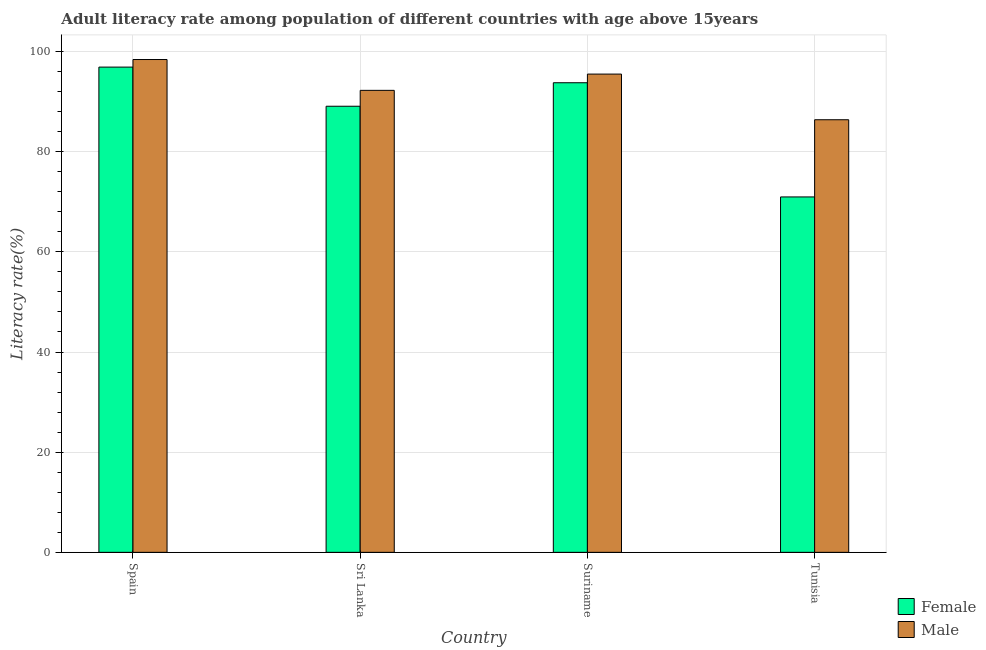Are the number of bars on each tick of the X-axis equal?
Make the answer very short. Yes. What is the label of the 2nd group of bars from the left?
Your response must be concise. Sri Lanka. In how many cases, is the number of bars for a given country not equal to the number of legend labels?
Ensure brevity in your answer.  0. What is the male adult literacy rate in Sri Lanka?
Your answer should be compact. 92.24. Across all countries, what is the maximum female adult literacy rate?
Your answer should be very brief. 96.89. Across all countries, what is the minimum male adult literacy rate?
Give a very brief answer. 86.38. In which country was the male adult literacy rate maximum?
Provide a short and direct response. Spain. In which country was the female adult literacy rate minimum?
Provide a short and direct response. Tunisia. What is the total female adult literacy rate in the graph?
Ensure brevity in your answer.  350.69. What is the difference between the male adult literacy rate in Spain and that in Sri Lanka?
Keep it short and to the point. 6.16. What is the difference between the female adult literacy rate in Sri Lanka and the male adult literacy rate in Spain?
Ensure brevity in your answer.  -9.33. What is the average female adult literacy rate per country?
Your answer should be very brief. 87.67. What is the difference between the male adult literacy rate and female adult literacy rate in Tunisia?
Keep it short and to the point. 15.41. In how many countries, is the female adult literacy rate greater than 52 %?
Keep it short and to the point. 4. What is the ratio of the male adult literacy rate in Spain to that in Sri Lanka?
Your answer should be compact. 1.07. Is the female adult literacy rate in Spain less than that in Tunisia?
Your response must be concise. No. What is the difference between the highest and the second highest female adult literacy rate?
Make the answer very short. 3.12. What is the difference between the highest and the lowest male adult literacy rate?
Your answer should be very brief. 12.03. Is the sum of the female adult literacy rate in Spain and Tunisia greater than the maximum male adult literacy rate across all countries?
Your answer should be compact. Yes. How many bars are there?
Ensure brevity in your answer.  8. What is the difference between two consecutive major ticks on the Y-axis?
Your response must be concise. 20. Are the values on the major ticks of Y-axis written in scientific E-notation?
Offer a very short reply. No. Does the graph contain grids?
Your answer should be very brief. Yes. What is the title of the graph?
Provide a short and direct response. Adult literacy rate among population of different countries with age above 15years. Does "Public funds" appear as one of the legend labels in the graph?
Your response must be concise. No. What is the label or title of the X-axis?
Provide a short and direct response. Country. What is the label or title of the Y-axis?
Your response must be concise. Literacy rate(%). What is the Literacy rate(%) in Female in Spain?
Ensure brevity in your answer.  96.89. What is the Literacy rate(%) of Male in Spain?
Your answer should be very brief. 98.4. What is the Literacy rate(%) in Female in Sri Lanka?
Ensure brevity in your answer.  89.07. What is the Literacy rate(%) in Male in Sri Lanka?
Offer a terse response. 92.24. What is the Literacy rate(%) in Female in Suriname?
Your response must be concise. 93.77. What is the Literacy rate(%) of Male in Suriname?
Give a very brief answer. 95.49. What is the Literacy rate(%) of Female in Tunisia?
Your answer should be very brief. 70.96. What is the Literacy rate(%) of Male in Tunisia?
Keep it short and to the point. 86.38. Across all countries, what is the maximum Literacy rate(%) in Female?
Keep it short and to the point. 96.89. Across all countries, what is the maximum Literacy rate(%) in Male?
Keep it short and to the point. 98.4. Across all countries, what is the minimum Literacy rate(%) of Female?
Your response must be concise. 70.96. Across all countries, what is the minimum Literacy rate(%) in Male?
Ensure brevity in your answer.  86.38. What is the total Literacy rate(%) in Female in the graph?
Your answer should be compact. 350.69. What is the total Literacy rate(%) of Male in the graph?
Provide a succinct answer. 372.51. What is the difference between the Literacy rate(%) in Female in Spain and that in Sri Lanka?
Offer a terse response. 7.81. What is the difference between the Literacy rate(%) in Male in Spain and that in Sri Lanka?
Your answer should be very brief. 6.16. What is the difference between the Literacy rate(%) in Female in Spain and that in Suriname?
Your answer should be compact. 3.12. What is the difference between the Literacy rate(%) of Male in Spain and that in Suriname?
Your answer should be compact. 2.91. What is the difference between the Literacy rate(%) in Female in Spain and that in Tunisia?
Offer a very short reply. 25.92. What is the difference between the Literacy rate(%) of Male in Spain and that in Tunisia?
Your response must be concise. 12.03. What is the difference between the Literacy rate(%) of Female in Sri Lanka and that in Suriname?
Make the answer very short. -4.69. What is the difference between the Literacy rate(%) of Male in Sri Lanka and that in Suriname?
Your answer should be very brief. -3.25. What is the difference between the Literacy rate(%) in Female in Sri Lanka and that in Tunisia?
Your response must be concise. 18.11. What is the difference between the Literacy rate(%) in Male in Sri Lanka and that in Tunisia?
Your response must be concise. 5.87. What is the difference between the Literacy rate(%) in Female in Suriname and that in Tunisia?
Your answer should be very brief. 22.8. What is the difference between the Literacy rate(%) of Male in Suriname and that in Tunisia?
Your response must be concise. 9.12. What is the difference between the Literacy rate(%) of Female in Spain and the Literacy rate(%) of Male in Sri Lanka?
Make the answer very short. 4.64. What is the difference between the Literacy rate(%) in Female in Spain and the Literacy rate(%) in Male in Suriname?
Provide a short and direct response. 1.39. What is the difference between the Literacy rate(%) in Female in Spain and the Literacy rate(%) in Male in Tunisia?
Keep it short and to the point. 10.51. What is the difference between the Literacy rate(%) of Female in Sri Lanka and the Literacy rate(%) of Male in Suriname?
Your response must be concise. -6.42. What is the difference between the Literacy rate(%) of Female in Sri Lanka and the Literacy rate(%) of Male in Tunisia?
Ensure brevity in your answer.  2.7. What is the difference between the Literacy rate(%) of Female in Suriname and the Literacy rate(%) of Male in Tunisia?
Your answer should be very brief. 7.39. What is the average Literacy rate(%) in Female per country?
Provide a short and direct response. 87.67. What is the average Literacy rate(%) in Male per country?
Provide a short and direct response. 93.13. What is the difference between the Literacy rate(%) of Female and Literacy rate(%) of Male in Spain?
Provide a succinct answer. -1.52. What is the difference between the Literacy rate(%) of Female and Literacy rate(%) of Male in Sri Lanka?
Your answer should be very brief. -3.17. What is the difference between the Literacy rate(%) in Female and Literacy rate(%) in Male in Suriname?
Your answer should be very brief. -1.73. What is the difference between the Literacy rate(%) of Female and Literacy rate(%) of Male in Tunisia?
Your answer should be very brief. -15.41. What is the ratio of the Literacy rate(%) in Female in Spain to that in Sri Lanka?
Keep it short and to the point. 1.09. What is the ratio of the Literacy rate(%) of Male in Spain to that in Sri Lanka?
Your answer should be very brief. 1.07. What is the ratio of the Literacy rate(%) of Male in Spain to that in Suriname?
Provide a succinct answer. 1.03. What is the ratio of the Literacy rate(%) of Female in Spain to that in Tunisia?
Ensure brevity in your answer.  1.37. What is the ratio of the Literacy rate(%) in Male in Spain to that in Tunisia?
Make the answer very short. 1.14. What is the ratio of the Literacy rate(%) in Female in Sri Lanka to that in Tunisia?
Your answer should be compact. 1.26. What is the ratio of the Literacy rate(%) of Male in Sri Lanka to that in Tunisia?
Your response must be concise. 1.07. What is the ratio of the Literacy rate(%) in Female in Suriname to that in Tunisia?
Provide a short and direct response. 1.32. What is the ratio of the Literacy rate(%) of Male in Suriname to that in Tunisia?
Keep it short and to the point. 1.11. What is the difference between the highest and the second highest Literacy rate(%) of Female?
Your response must be concise. 3.12. What is the difference between the highest and the second highest Literacy rate(%) in Male?
Offer a very short reply. 2.91. What is the difference between the highest and the lowest Literacy rate(%) in Female?
Provide a short and direct response. 25.92. What is the difference between the highest and the lowest Literacy rate(%) in Male?
Provide a short and direct response. 12.03. 